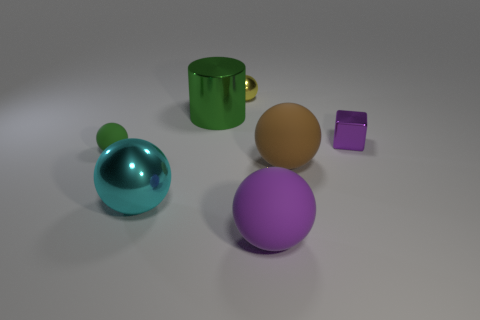Subtract all tiny shiny balls. How many balls are left? 4 Subtract all green spheres. How many spheres are left? 4 Subtract 1 cubes. How many cubes are left? 0 Add 1 small rubber things. How many objects exist? 8 Subtract all cyan cylinders. Subtract all cyan balls. How many cylinders are left? 1 Add 1 cyan objects. How many cyan objects are left? 2 Add 5 green cylinders. How many green cylinders exist? 6 Subtract 1 cyan balls. How many objects are left? 6 Subtract all blocks. How many objects are left? 6 Subtract all purple cylinders. How many blue blocks are left? 0 